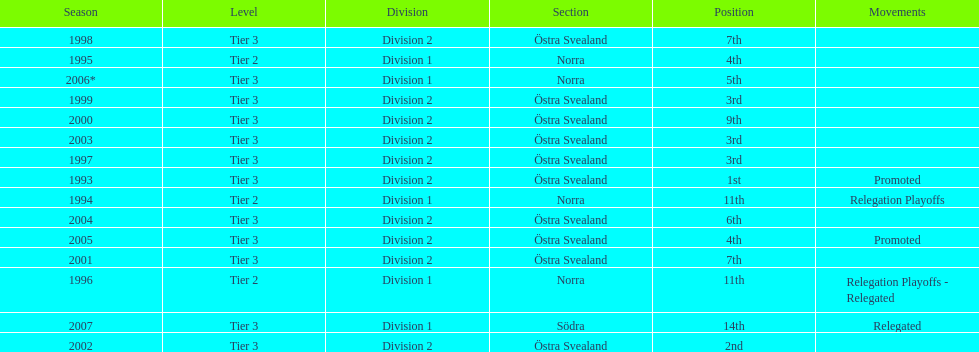In what season did visby if gute fk finish first in division 2 tier 3? 1993. 